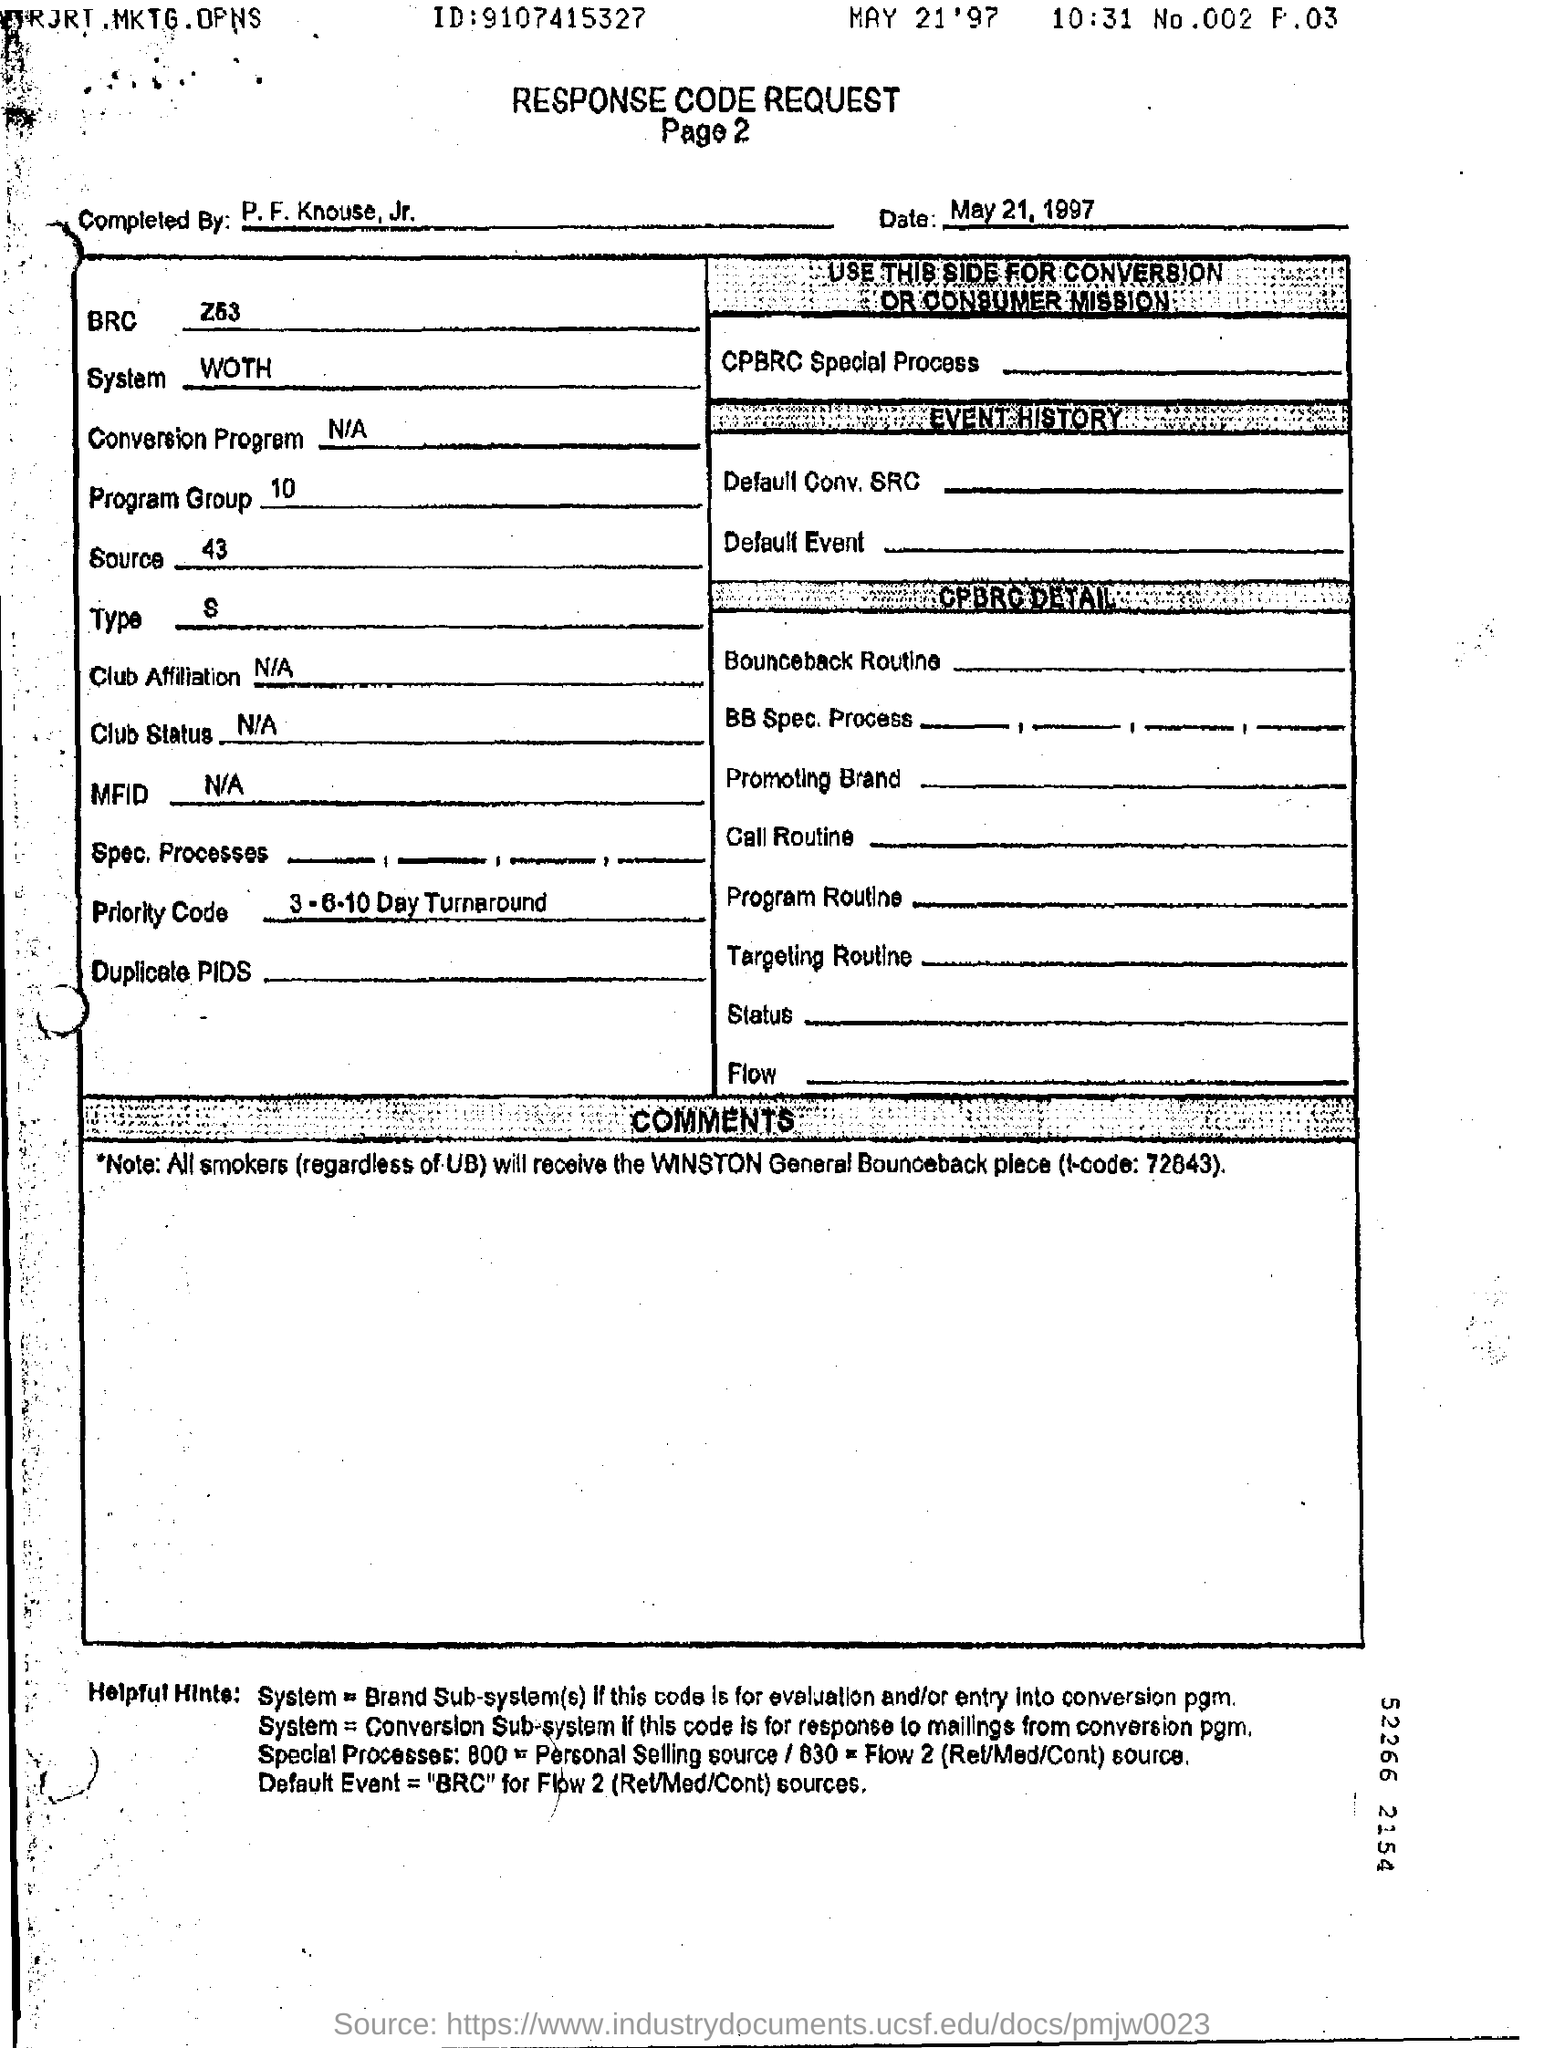What is the document about?
Provide a succinct answer. RESPONSE CODE REQUEST. What type of form is this?
Your answer should be very brief. RESPONSE CODE REQUEST. What is the ID number given?
Provide a succinct answer. 9107415327. What is the date given?
Your answer should be very brief. May 21, 1997. What is the priority code given?
Give a very brief answer. 3-6-10 Day Turnaround. What is the System given?
Provide a succinct answer. WOTH. 